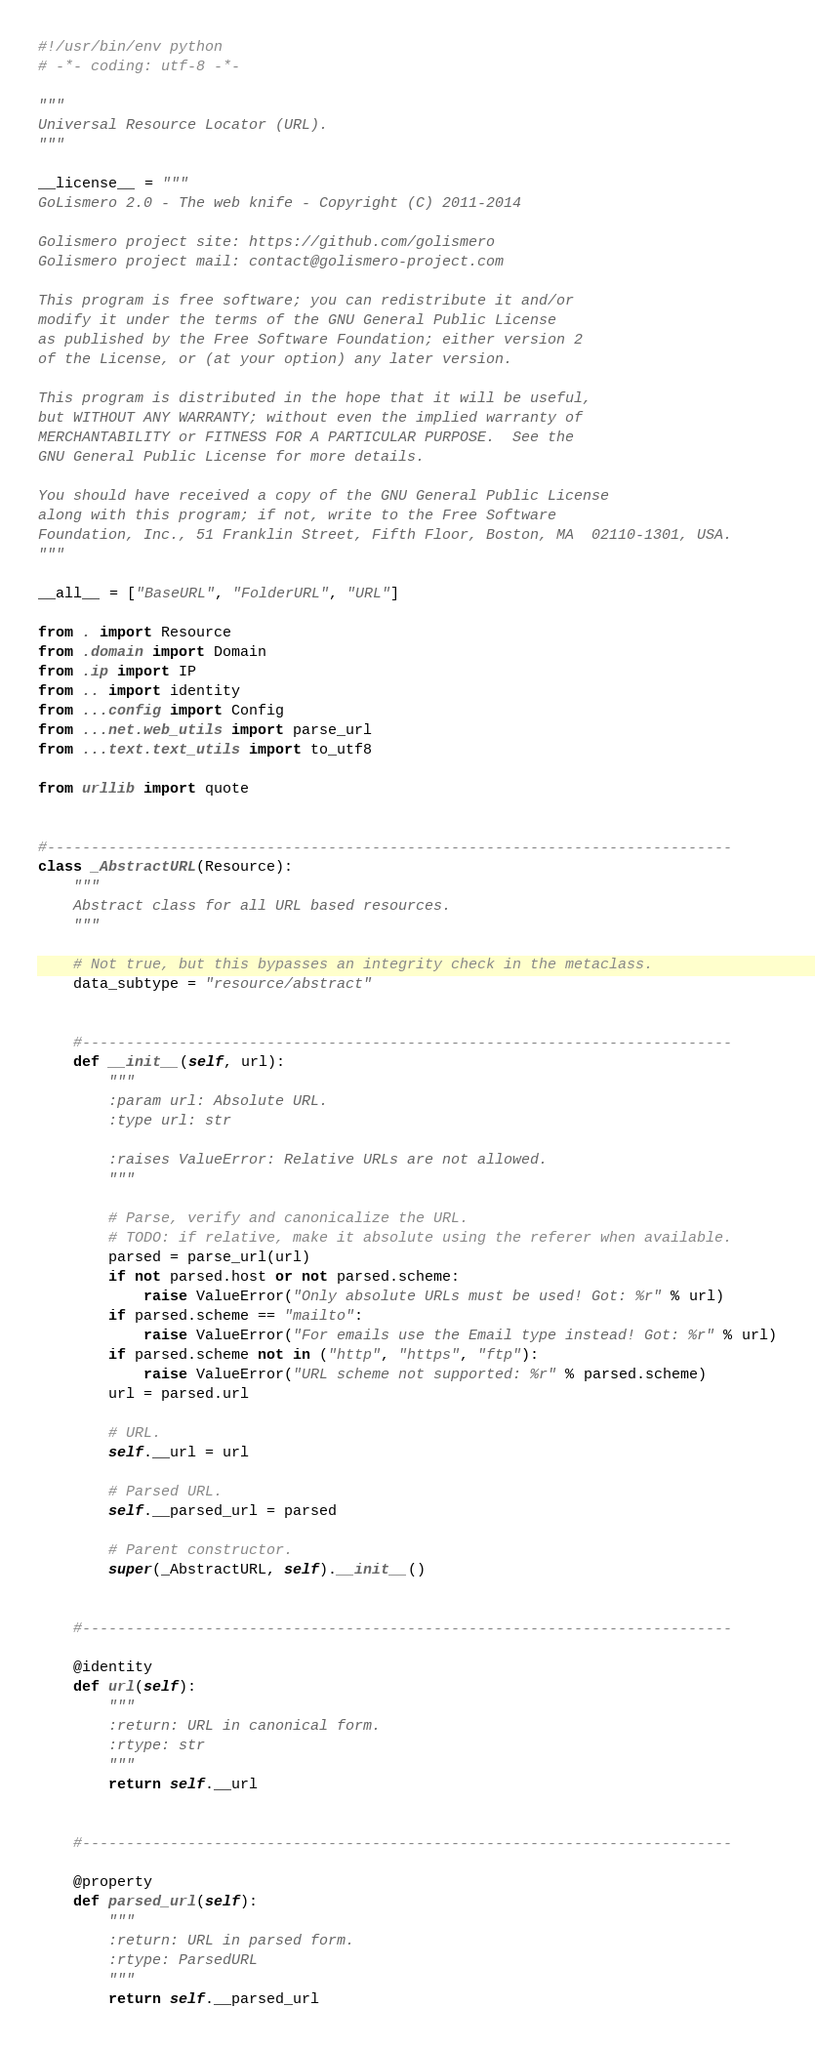<code> <loc_0><loc_0><loc_500><loc_500><_Python_>#!/usr/bin/env python
# -*- coding: utf-8 -*-

"""
Universal Resource Locator (URL).
"""

__license__ = """
GoLismero 2.0 - The web knife - Copyright (C) 2011-2014

Golismero project site: https://github.com/golismero
Golismero project mail: contact@golismero-project.com

This program is free software; you can redistribute it and/or
modify it under the terms of the GNU General Public License
as published by the Free Software Foundation; either version 2
of the License, or (at your option) any later version.

This program is distributed in the hope that it will be useful,
but WITHOUT ANY WARRANTY; without even the implied warranty of
MERCHANTABILITY or FITNESS FOR A PARTICULAR PURPOSE.  See the
GNU General Public License for more details.

You should have received a copy of the GNU General Public License
along with this program; if not, write to the Free Software
Foundation, Inc., 51 Franklin Street, Fifth Floor, Boston, MA  02110-1301, USA.
"""

__all__ = ["BaseURL", "FolderURL", "URL"]

from . import Resource
from .domain import Domain
from .ip import IP
from .. import identity
from ...config import Config
from ...net.web_utils import parse_url
from ...text.text_utils import to_utf8

from urllib import quote


#------------------------------------------------------------------------------
class _AbstractURL(Resource):
    """
    Abstract class for all URL based resources.
    """

    # Not true, but this bypasses an integrity check in the metaclass.
    data_subtype = "resource/abstract"


    #--------------------------------------------------------------------------
    def __init__(self, url):
        """
        :param url: Absolute URL.
        :type url: str

        :raises ValueError: Relative URLs are not allowed.
        """

        # Parse, verify and canonicalize the URL.
        # TODO: if relative, make it absolute using the referer when available.
        parsed = parse_url(url)
        if not parsed.host or not parsed.scheme:
            raise ValueError("Only absolute URLs must be used! Got: %r" % url)
        if parsed.scheme == "mailto":
            raise ValueError("For emails use the Email type instead! Got: %r" % url)
        if parsed.scheme not in ("http", "https", "ftp"):
            raise ValueError("URL scheme not supported: %r" % parsed.scheme)
        url = parsed.url

        # URL.
        self.__url = url

        # Parsed URL.
        self.__parsed_url = parsed

        # Parent constructor.
        super(_AbstractURL, self).__init__()


    #--------------------------------------------------------------------------

    @identity
    def url(self):
        """
        :return: URL in canonical form.
        :rtype: str
        """
        return self.__url


    #--------------------------------------------------------------------------

    @property
    def parsed_url(self):
        """
        :return: URL in parsed form.
        :rtype: ParsedURL
        """
        return self.__parsed_url
</code> 